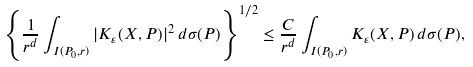<formula> <loc_0><loc_0><loc_500><loc_500>\left \{ \frac { 1 } { r ^ { d } } \int _ { I ( P _ { 0 } , r ) } | K _ { \varepsilon } ( X , P ) | ^ { 2 } \, d \sigma ( P ) \right \} ^ { 1 / 2 } \leq \frac { C } { r ^ { d } } \int _ { I ( P _ { 0 } , r ) } K _ { \varepsilon } ( X , P ) \, d \sigma ( P ) ,</formula> 